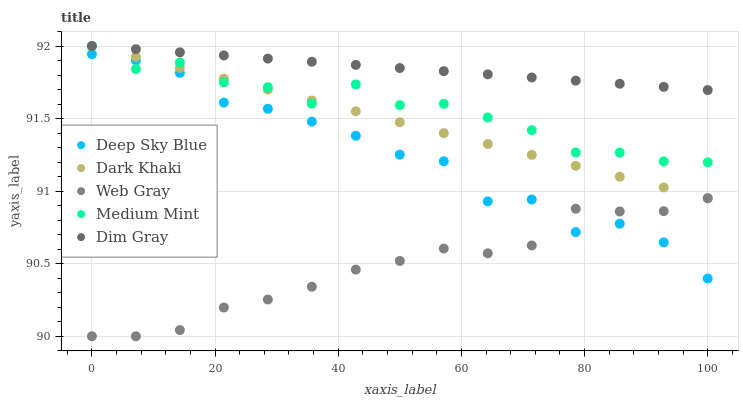Does Web Gray have the minimum area under the curve?
Answer yes or no. Yes. Does Dim Gray have the maximum area under the curve?
Answer yes or no. Yes. Does Medium Mint have the minimum area under the curve?
Answer yes or no. No. Does Medium Mint have the maximum area under the curve?
Answer yes or no. No. Is Dark Khaki the smoothest?
Answer yes or no. Yes. Is Deep Sky Blue the roughest?
Answer yes or no. Yes. Is Medium Mint the smoothest?
Answer yes or no. No. Is Medium Mint the roughest?
Answer yes or no. No. Does Web Gray have the lowest value?
Answer yes or no. Yes. Does Medium Mint have the lowest value?
Answer yes or no. No. Does Dim Gray have the highest value?
Answer yes or no. Yes. Does Web Gray have the highest value?
Answer yes or no. No. Is Web Gray less than Medium Mint?
Answer yes or no. Yes. Is Dark Khaki greater than Deep Sky Blue?
Answer yes or no. Yes. Does Medium Mint intersect Dark Khaki?
Answer yes or no. Yes. Is Medium Mint less than Dark Khaki?
Answer yes or no. No. Is Medium Mint greater than Dark Khaki?
Answer yes or no. No. Does Web Gray intersect Medium Mint?
Answer yes or no. No. 